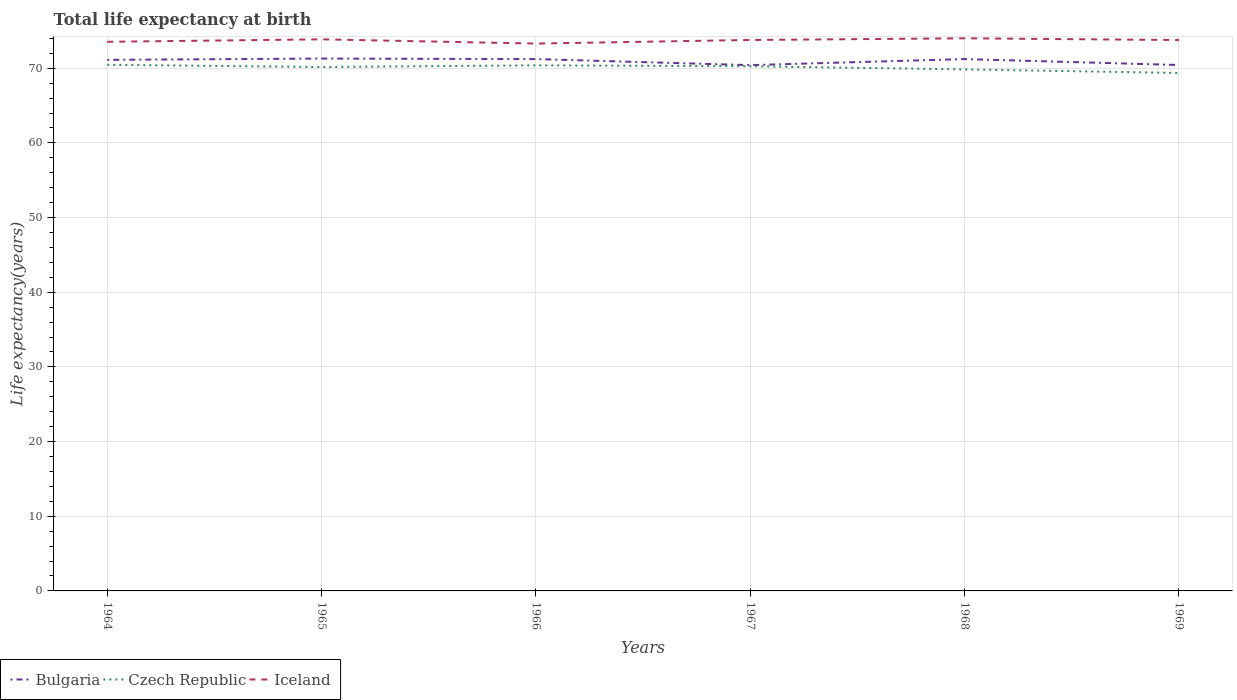Does the line corresponding to Bulgaria intersect with the line corresponding to Iceland?
Keep it short and to the point. No. Is the number of lines equal to the number of legend labels?
Provide a short and direct response. Yes. Across all years, what is the maximum life expectancy at birth in in Czech Republic?
Your answer should be compact. 69.37. In which year was the life expectancy at birth in in Iceland maximum?
Your answer should be very brief. 1966. What is the total life expectancy at birth in in Czech Republic in the graph?
Your answer should be very brief. 0.42. What is the difference between the highest and the second highest life expectancy at birth in in Czech Republic?
Give a very brief answer. 1.09. What is the difference between the highest and the lowest life expectancy at birth in in Iceland?
Offer a terse response. 4. Is the life expectancy at birth in in Bulgaria strictly greater than the life expectancy at birth in in Czech Republic over the years?
Provide a short and direct response. No. What is the difference between two consecutive major ticks on the Y-axis?
Your answer should be very brief. 10. Are the values on the major ticks of Y-axis written in scientific E-notation?
Your answer should be very brief. No. Does the graph contain any zero values?
Ensure brevity in your answer.  No. Does the graph contain grids?
Ensure brevity in your answer.  Yes. How are the legend labels stacked?
Ensure brevity in your answer.  Horizontal. What is the title of the graph?
Provide a short and direct response. Total life expectancy at birth. Does "South Sudan" appear as one of the legend labels in the graph?
Provide a short and direct response. No. What is the label or title of the X-axis?
Your answer should be compact. Years. What is the label or title of the Y-axis?
Your response must be concise. Life expectancy(years). What is the Life expectancy(years) in Bulgaria in 1964?
Your response must be concise. 71.12. What is the Life expectancy(years) of Czech Republic in 1964?
Provide a short and direct response. 70.46. What is the Life expectancy(years) in Iceland in 1964?
Provide a succinct answer. 73.54. What is the Life expectancy(years) of Bulgaria in 1965?
Ensure brevity in your answer.  71.29. What is the Life expectancy(years) of Czech Republic in 1965?
Provide a short and direct response. 70.16. What is the Life expectancy(years) of Iceland in 1965?
Your response must be concise. 73.87. What is the Life expectancy(years) in Bulgaria in 1966?
Your answer should be compact. 71.22. What is the Life expectancy(years) of Czech Republic in 1966?
Give a very brief answer. 70.38. What is the Life expectancy(years) in Iceland in 1966?
Your response must be concise. 73.3. What is the Life expectancy(years) in Bulgaria in 1967?
Keep it short and to the point. 70.41. What is the Life expectancy(years) of Czech Republic in 1967?
Give a very brief answer. 70.26. What is the Life expectancy(years) in Iceland in 1967?
Your answer should be very brief. 73.78. What is the Life expectancy(years) in Bulgaria in 1968?
Give a very brief answer. 71.23. What is the Life expectancy(years) in Czech Republic in 1968?
Offer a terse response. 69.84. What is the Life expectancy(years) in Iceland in 1968?
Your answer should be very brief. 74.01. What is the Life expectancy(years) of Bulgaria in 1969?
Provide a succinct answer. 70.43. What is the Life expectancy(years) of Czech Republic in 1969?
Keep it short and to the point. 69.37. What is the Life expectancy(years) in Iceland in 1969?
Keep it short and to the point. 73.78. Across all years, what is the maximum Life expectancy(years) of Bulgaria?
Provide a succinct answer. 71.29. Across all years, what is the maximum Life expectancy(years) in Czech Republic?
Provide a short and direct response. 70.46. Across all years, what is the maximum Life expectancy(years) of Iceland?
Provide a short and direct response. 74.01. Across all years, what is the minimum Life expectancy(years) in Bulgaria?
Your answer should be compact. 70.41. Across all years, what is the minimum Life expectancy(years) of Czech Republic?
Your response must be concise. 69.37. Across all years, what is the minimum Life expectancy(years) in Iceland?
Keep it short and to the point. 73.3. What is the total Life expectancy(years) in Bulgaria in the graph?
Your response must be concise. 425.71. What is the total Life expectancy(years) of Czech Republic in the graph?
Give a very brief answer. 420.48. What is the total Life expectancy(years) of Iceland in the graph?
Ensure brevity in your answer.  442.28. What is the difference between the Life expectancy(years) of Bulgaria in 1964 and that in 1965?
Ensure brevity in your answer.  -0.17. What is the difference between the Life expectancy(years) in Czech Republic in 1964 and that in 1965?
Your answer should be very brief. 0.3. What is the difference between the Life expectancy(years) of Iceland in 1964 and that in 1965?
Provide a succinct answer. -0.33. What is the difference between the Life expectancy(years) in Bulgaria in 1964 and that in 1966?
Provide a short and direct response. -0.1. What is the difference between the Life expectancy(years) of Czech Republic in 1964 and that in 1966?
Your response must be concise. 0.07. What is the difference between the Life expectancy(years) of Iceland in 1964 and that in 1966?
Ensure brevity in your answer.  0.24. What is the difference between the Life expectancy(years) of Bulgaria in 1964 and that in 1967?
Offer a very short reply. 0.71. What is the difference between the Life expectancy(years) in Czech Republic in 1964 and that in 1967?
Your answer should be compact. 0.2. What is the difference between the Life expectancy(years) of Iceland in 1964 and that in 1967?
Give a very brief answer. -0.24. What is the difference between the Life expectancy(years) of Bulgaria in 1964 and that in 1968?
Provide a succinct answer. -0.1. What is the difference between the Life expectancy(years) of Czech Republic in 1964 and that in 1968?
Offer a terse response. 0.62. What is the difference between the Life expectancy(years) in Iceland in 1964 and that in 1968?
Provide a short and direct response. -0.46. What is the difference between the Life expectancy(years) of Bulgaria in 1964 and that in 1969?
Provide a succinct answer. 0.69. What is the difference between the Life expectancy(years) in Czech Republic in 1964 and that in 1969?
Offer a very short reply. 1.09. What is the difference between the Life expectancy(years) of Iceland in 1964 and that in 1969?
Your answer should be very brief. -0.23. What is the difference between the Life expectancy(years) of Bulgaria in 1965 and that in 1966?
Provide a succinct answer. 0.07. What is the difference between the Life expectancy(years) of Czech Republic in 1965 and that in 1966?
Offer a very short reply. -0.22. What is the difference between the Life expectancy(years) in Iceland in 1965 and that in 1966?
Your response must be concise. 0.57. What is the difference between the Life expectancy(years) in Czech Republic in 1965 and that in 1967?
Provide a short and direct response. -0.1. What is the difference between the Life expectancy(years) in Iceland in 1965 and that in 1967?
Keep it short and to the point. 0.09. What is the difference between the Life expectancy(years) of Bulgaria in 1965 and that in 1968?
Keep it short and to the point. 0.07. What is the difference between the Life expectancy(years) of Czech Republic in 1965 and that in 1968?
Keep it short and to the point. 0.32. What is the difference between the Life expectancy(years) in Iceland in 1965 and that in 1968?
Make the answer very short. -0.14. What is the difference between the Life expectancy(years) in Bulgaria in 1965 and that in 1969?
Your answer should be compact. 0.86. What is the difference between the Life expectancy(years) of Czech Republic in 1965 and that in 1969?
Keep it short and to the point. 0.8. What is the difference between the Life expectancy(years) of Iceland in 1965 and that in 1969?
Provide a short and direct response. 0.09. What is the difference between the Life expectancy(years) in Bulgaria in 1966 and that in 1967?
Your answer should be compact. 0.81. What is the difference between the Life expectancy(years) in Czech Republic in 1966 and that in 1967?
Make the answer very short. 0.12. What is the difference between the Life expectancy(years) in Iceland in 1966 and that in 1967?
Your answer should be very brief. -0.48. What is the difference between the Life expectancy(years) in Bulgaria in 1966 and that in 1968?
Ensure brevity in your answer.  -0. What is the difference between the Life expectancy(years) of Czech Republic in 1966 and that in 1968?
Your answer should be compact. 0.54. What is the difference between the Life expectancy(years) of Iceland in 1966 and that in 1968?
Provide a short and direct response. -0.71. What is the difference between the Life expectancy(years) of Bulgaria in 1966 and that in 1969?
Provide a succinct answer. 0.79. What is the difference between the Life expectancy(years) in Czech Republic in 1966 and that in 1969?
Offer a very short reply. 1.02. What is the difference between the Life expectancy(years) of Iceland in 1966 and that in 1969?
Provide a succinct answer. -0.48. What is the difference between the Life expectancy(years) of Bulgaria in 1967 and that in 1968?
Offer a very short reply. -0.81. What is the difference between the Life expectancy(years) of Czech Republic in 1967 and that in 1968?
Keep it short and to the point. 0.42. What is the difference between the Life expectancy(years) of Iceland in 1967 and that in 1968?
Give a very brief answer. -0.22. What is the difference between the Life expectancy(years) in Bulgaria in 1967 and that in 1969?
Your response must be concise. -0.02. What is the difference between the Life expectancy(years) of Czech Republic in 1967 and that in 1969?
Your answer should be very brief. 0.9. What is the difference between the Life expectancy(years) of Iceland in 1967 and that in 1969?
Give a very brief answer. 0.01. What is the difference between the Life expectancy(years) in Bulgaria in 1968 and that in 1969?
Give a very brief answer. 0.8. What is the difference between the Life expectancy(years) in Czech Republic in 1968 and that in 1969?
Provide a succinct answer. 0.47. What is the difference between the Life expectancy(years) in Iceland in 1968 and that in 1969?
Give a very brief answer. 0.23. What is the difference between the Life expectancy(years) in Bulgaria in 1964 and the Life expectancy(years) in Czech Republic in 1965?
Offer a very short reply. 0.96. What is the difference between the Life expectancy(years) of Bulgaria in 1964 and the Life expectancy(years) of Iceland in 1965?
Your response must be concise. -2.75. What is the difference between the Life expectancy(years) in Czech Republic in 1964 and the Life expectancy(years) in Iceland in 1965?
Your answer should be very brief. -3.41. What is the difference between the Life expectancy(years) in Bulgaria in 1964 and the Life expectancy(years) in Czech Republic in 1966?
Offer a very short reply. 0.74. What is the difference between the Life expectancy(years) of Bulgaria in 1964 and the Life expectancy(years) of Iceland in 1966?
Provide a succinct answer. -2.18. What is the difference between the Life expectancy(years) of Czech Republic in 1964 and the Life expectancy(years) of Iceland in 1966?
Your response must be concise. -2.84. What is the difference between the Life expectancy(years) in Bulgaria in 1964 and the Life expectancy(years) in Iceland in 1967?
Your answer should be compact. -2.66. What is the difference between the Life expectancy(years) in Czech Republic in 1964 and the Life expectancy(years) in Iceland in 1967?
Your response must be concise. -3.32. What is the difference between the Life expectancy(years) of Bulgaria in 1964 and the Life expectancy(years) of Czech Republic in 1968?
Provide a short and direct response. 1.28. What is the difference between the Life expectancy(years) in Bulgaria in 1964 and the Life expectancy(years) in Iceland in 1968?
Offer a terse response. -2.88. What is the difference between the Life expectancy(years) in Czech Republic in 1964 and the Life expectancy(years) in Iceland in 1968?
Keep it short and to the point. -3.55. What is the difference between the Life expectancy(years) in Bulgaria in 1964 and the Life expectancy(years) in Czech Republic in 1969?
Provide a succinct answer. 1.75. What is the difference between the Life expectancy(years) in Bulgaria in 1964 and the Life expectancy(years) in Iceland in 1969?
Your answer should be compact. -2.66. What is the difference between the Life expectancy(years) of Czech Republic in 1964 and the Life expectancy(years) of Iceland in 1969?
Offer a terse response. -3.32. What is the difference between the Life expectancy(years) in Bulgaria in 1965 and the Life expectancy(years) in Czech Republic in 1966?
Make the answer very short. 0.91. What is the difference between the Life expectancy(years) of Bulgaria in 1965 and the Life expectancy(years) of Iceland in 1966?
Offer a terse response. -2.01. What is the difference between the Life expectancy(years) of Czech Republic in 1965 and the Life expectancy(years) of Iceland in 1966?
Make the answer very short. -3.14. What is the difference between the Life expectancy(years) of Bulgaria in 1965 and the Life expectancy(years) of Czech Republic in 1967?
Make the answer very short. 1.03. What is the difference between the Life expectancy(years) of Bulgaria in 1965 and the Life expectancy(years) of Iceland in 1967?
Offer a very short reply. -2.49. What is the difference between the Life expectancy(years) of Czech Republic in 1965 and the Life expectancy(years) of Iceland in 1967?
Provide a succinct answer. -3.62. What is the difference between the Life expectancy(years) in Bulgaria in 1965 and the Life expectancy(years) in Czech Republic in 1968?
Your answer should be very brief. 1.45. What is the difference between the Life expectancy(years) in Bulgaria in 1965 and the Life expectancy(years) in Iceland in 1968?
Your answer should be compact. -2.71. What is the difference between the Life expectancy(years) of Czech Republic in 1965 and the Life expectancy(years) of Iceland in 1968?
Your answer should be compact. -3.84. What is the difference between the Life expectancy(years) in Bulgaria in 1965 and the Life expectancy(years) in Czech Republic in 1969?
Offer a very short reply. 1.93. What is the difference between the Life expectancy(years) of Bulgaria in 1965 and the Life expectancy(years) of Iceland in 1969?
Make the answer very short. -2.48. What is the difference between the Life expectancy(years) of Czech Republic in 1965 and the Life expectancy(years) of Iceland in 1969?
Ensure brevity in your answer.  -3.61. What is the difference between the Life expectancy(years) of Bulgaria in 1966 and the Life expectancy(years) of Czech Republic in 1967?
Offer a very short reply. 0.96. What is the difference between the Life expectancy(years) of Bulgaria in 1966 and the Life expectancy(years) of Iceland in 1967?
Your answer should be compact. -2.56. What is the difference between the Life expectancy(years) in Czech Republic in 1966 and the Life expectancy(years) in Iceland in 1967?
Your answer should be very brief. -3.4. What is the difference between the Life expectancy(years) in Bulgaria in 1966 and the Life expectancy(years) in Czech Republic in 1968?
Give a very brief answer. 1.38. What is the difference between the Life expectancy(years) of Bulgaria in 1966 and the Life expectancy(years) of Iceland in 1968?
Offer a terse response. -2.78. What is the difference between the Life expectancy(years) in Czech Republic in 1966 and the Life expectancy(years) in Iceland in 1968?
Provide a short and direct response. -3.62. What is the difference between the Life expectancy(years) of Bulgaria in 1966 and the Life expectancy(years) of Czech Republic in 1969?
Your response must be concise. 1.86. What is the difference between the Life expectancy(years) in Bulgaria in 1966 and the Life expectancy(years) in Iceland in 1969?
Your response must be concise. -2.55. What is the difference between the Life expectancy(years) in Czech Republic in 1966 and the Life expectancy(years) in Iceland in 1969?
Offer a terse response. -3.39. What is the difference between the Life expectancy(years) of Bulgaria in 1967 and the Life expectancy(years) of Czech Republic in 1968?
Give a very brief answer. 0.57. What is the difference between the Life expectancy(years) in Bulgaria in 1967 and the Life expectancy(years) in Iceland in 1968?
Give a very brief answer. -3.59. What is the difference between the Life expectancy(years) of Czech Republic in 1967 and the Life expectancy(years) of Iceland in 1968?
Your response must be concise. -3.74. What is the difference between the Life expectancy(years) of Bulgaria in 1967 and the Life expectancy(years) of Czech Republic in 1969?
Keep it short and to the point. 1.05. What is the difference between the Life expectancy(years) in Bulgaria in 1967 and the Life expectancy(years) in Iceland in 1969?
Provide a succinct answer. -3.36. What is the difference between the Life expectancy(years) of Czech Republic in 1967 and the Life expectancy(years) of Iceland in 1969?
Your answer should be compact. -3.51. What is the difference between the Life expectancy(years) of Bulgaria in 1968 and the Life expectancy(years) of Czech Republic in 1969?
Provide a succinct answer. 1.86. What is the difference between the Life expectancy(years) of Bulgaria in 1968 and the Life expectancy(years) of Iceland in 1969?
Your answer should be compact. -2.55. What is the difference between the Life expectancy(years) in Czech Republic in 1968 and the Life expectancy(years) in Iceland in 1969?
Keep it short and to the point. -3.94. What is the average Life expectancy(years) of Bulgaria per year?
Provide a short and direct response. 70.95. What is the average Life expectancy(years) in Czech Republic per year?
Provide a short and direct response. 70.08. What is the average Life expectancy(years) of Iceland per year?
Ensure brevity in your answer.  73.71. In the year 1964, what is the difference between the Life expectancy(years) of Bulgaria and Life expectancy(years) of Czech Republic?
Ensure brevity in your answer.  0.66. In the year 1964, what is the difference between the Life expectancy(years) in Bulgaria and Life expectancy(years) in Iceland?
Provide a succinct answer. -2.42. In the year 1964, what is the difference between the Life expectancy(years) in Czech Republic and Life expectancy(years) in Iceland?
Make the answer very short. -3.08. In the year 1965, what is the difference between the Life expectancy(years) in Bulgaria and Life expectancy(years) in Czech Republic?
Give a very brief answer. 1.13. In the year 1965, what is the difference between the Life expectancy(years) in Bulgaria and Life expectancy(years) in Iceland?
Keep it short and to the point. -2.57. In the year 1965, what is the difference between the Life expectancy(years) in Czech Republic and Life expectancy(years) in Iceland?
Offer a terse response. -3.71. In the year 1966, what is the difference between the Life expectancy(years) in Bulgaria and Life expectancy(years) in Czech Republic?
Your response must be concise. 0.84. In the year 1966, what is the difference between the Life expectancy(years) in Bulgaria and Life expectancy(years) in Iceland?
Make the answer very short. -2.08. In the year 1966, what is the difference between the Life expectancy(years) of Czech Republic and Life expectancy(years) of Iceland?
Provide a succinct answer. -2.92. In the year 1967, what is the difference between the Life expectancy(years) in Bulgaria and Life expectancy(years) in Czech Republic?
Offer a very short reply. 0.15. In the year 1967, what is the difference between the Life expectancy(years) in Bulgaria and Life expectancy(years) in Iceland?
Offer a very short reply. -3.37. In the year 1967, what is the difference between the Life expectancy(years) of Czech Republic and Life expectancy(years) of Iceland?
Your answer should be very brief. -3.52. In the year 1968, what is the difference between the Life expectancy(years) in Bulgaria and Life expectancy(years) in Czech Republic?
Your answer should be compact. 1.38. In the year 1968, what is the difference between the Life expectancy(years) of Bulgaria and Life expectancy(years) of Iceland?
Your response must be concise. -2.78. In the year 1968, what is the difference between the Life expectancy(years) of Czech Republic and Life expectancy(years) of Iceland?
Give a very brief answer. -4.17. In the year 1969, what is the difference between the Life expectancy(years) of Bulgaria and Life expectancy(years) of Czech Republic?
Your answer should be very brief. 1.06. In the year 1969, what is the difference between the Life expectancy(years) of Bulgaria and Life expectancy(years) of Iceland?
Give a very brief answer. -3.35. In the year 1969, what is the difference between the Life expectancy(years) of Czech Republic and Life expectancy(years) of Iceland?
Make the answer very short. -4.41. What is the ratio of the Life expectancy(years) of Bulgaria in 1964 to that in 1965?
Your answer should be very brief. 1. What is the ratio of the Life expectancy(years) in Iceland in 1964 to that in 1965?
Give a very brief answer. 1. What is the ratio of the Life expectancy(years) in Bulgaria in 1964 to that in 1967?
Offer a terse response. 1.01. What is the ratio of the Life expectancy(years) in Czech Republic in 1964 to that in 1967?
Offer a very short reply. 1. What is the ratio of the Life expectancy(years) in Bulgaria in 1964 to that in 1968?
Offer a terse response. 1. What is the ratio of the Life expectancy(years) of Czech Republic in 1964 to that in 1968?
Your answer should be very brief. 1.01. What is the ratio of the Life expectancy(years) of Bulgaria in 1964 to that in 1969?
Your answer should be very brief. 1.01. What is the ratio of the Life expectancy(years) of Czech Republic in 1964 to that in 1969?
Give a very brief answer. 1.02. What is the ratio of the Life expectancy(years) in Iceland in 1964 to that in 1969?
Offer a terse response. 1. What is the ratio of the Life expectancy(years) of Bulgaria in 1965 to that in 1966?
Provide a succinct answer. 1. What is the ratio of the Life expectancy(years) of Iceland in 1965 to that in 1966?
Ensure brevity in your answer.  1.01. What is the ratio of the Life expectancy(years) in Bulgaria in 1965 to that in 1967?
Your answer should be compact. 1.01. What is the ratio of the Life expectancy(years) in Iceland in 1965 to that in 1967?
Your response must be concise. 1. What is the ratio of the Life expectancy(years) in Bulgaria in 1965 to that in 1969?
Your answer should be very brief. 1.01. What is the ratio of the Life expectancy(years) of Czech Republic in 1965 to that in 1969?
Your answer should be compact. 1.01. What is the ratio of the Life expectancy(years) of Bulgaria in 1966 to that in 1967?
Provide a succinct answer. 1.01. What is the ratio of the Life expectancy(years) of Czech Republic in 1966 to that in 1967?
Your answer should be very brief. 1. What is the ratio of the Life expectancy(years) of Bulgaria in 1966 to that in 1968?
Provide a succinct answer. 1. What is the ratio of the Life expectancy(years) of Bulgaria in 1966 to that in 1969?
Provide a succinct answer. 1.01. What is the ratio of the Life expectancy(years) in Czech Republic in 1966 to that in 1969?
Your answer should be very brief. 1.01. What is the ratio of the Life expectancy(years) in Bulgaria in 1967 to that in 1968?
Offer a very short reply. 0.99. What is the ratio of the Life expectancy(years) of Bulgaria in 1967 to that in 1969?
Offer a very short reply. 1. What is the ratio of the Life expectancy(years) of Czech Republic in 1967 to that in 1969?
Offer a terse response. 1.01. What is the ratio of the Life expectancy(years) of Iceland in 1967 to that in 1969?
Your answer should be compact. 1. What is the ratio of the Life expectancy(years) of Bulgaria in 1968 to that in 1969?
Offer a very short reply. 1.01. What is the ratio of the Life expectancy(years) of Czech Republic in 1968 to that in 1969?
Give a very brief answer. 1.01. What is the ratio of the Life expectancy(years) of Iceland in 1968 to that in 1969?
Offer a very short reply. 1. What is the difference between the highest and the second highest Life expectancy(years) of Bulgaria?
Make the answer very short. 0.07. What is the difference between the highest and the second highest Life expectancy(years) of Czech Republic?
Offer a very short reply. 0.07. What is the difference between the highest and the second highest Life expectancy(years) of Iceland?
Make the answer very short. 0.14. What is the difference between the highest and the lowest Life expectancy(years) in Bulgaria?
Give a very brief answer. 0.88. What is the difference between the highest and the lowest Life expectancy(years) of Czech Republic?
Make the answer very short. 1.09. What is the difference between the highest and the lowest Life expectancy(years) in Iceland?
Make the answer very short. 0.71. 